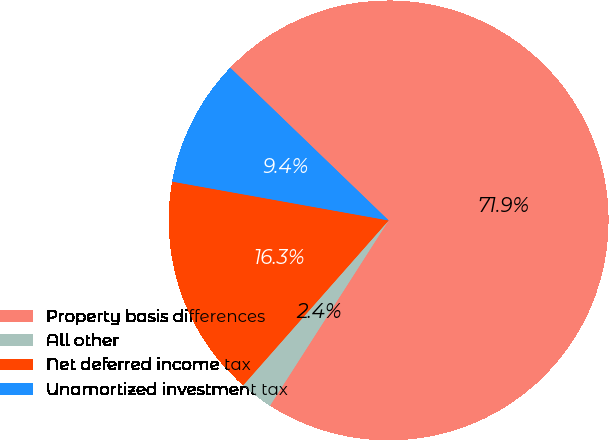Convert chart to OTSL. <chart><loc_0><loc_0><loc_500><loc_500><pie_chart><fcel>Property basis differences<fcel>All other<fcel>Net deferred income tax<fcel>Unamortized investment tax<nl><fcel>71.86%<fcel>2.44%<fcel>16.32%<fcel>9.38%<nl></chart> 